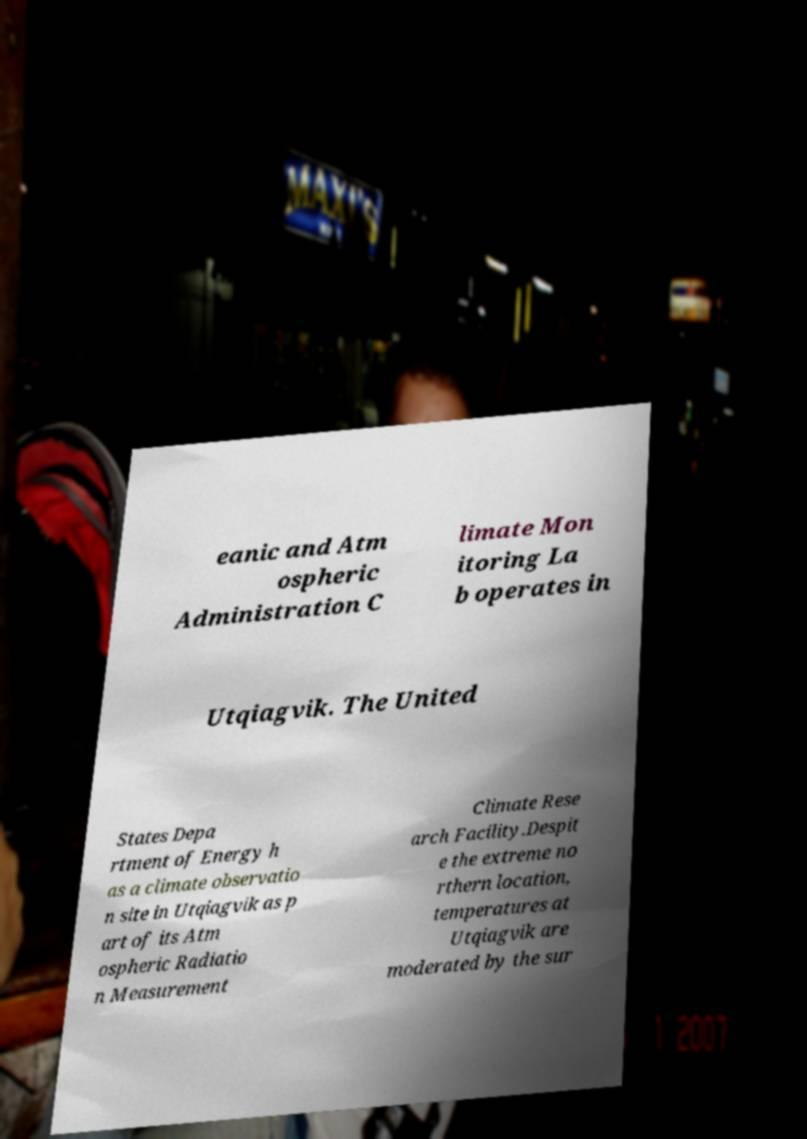What messages or text are displayed in this image? I need them in a readable, typed format. eanic and Atm ospheric Administration C limate Mon itoring La b operates in Utqiagvik. The United States Depa rtment of Energy h as a climate observatio n site in Utqiagvik as p art of its Atm ospheric Radiatio n Measurement Climate Rese arch Facility.Despit e the extreme no rthern location, temperatures at Utqiagvik are moderated by the sur 